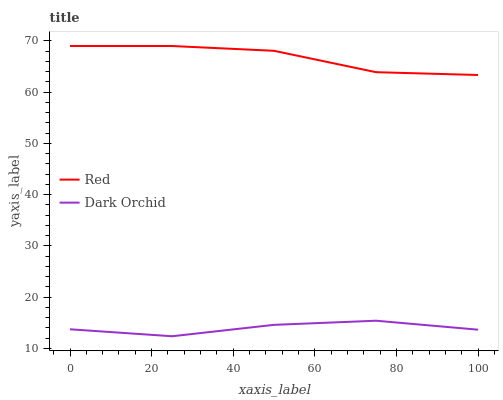Does Red have the minimum area under the curve?
Answer yes or no. No. Is Red the smoothest?
Answer yes or no. No. Does Red have the lowest value?
Answer yes or no. No. Is Dark Orchid less than Red?
Answer yes or no. Yes. Is Red greater than Dark Orchid?
Answer yes or no. Yes. Does Dark Orchid intersect Red?
Answer yes or no. No. 